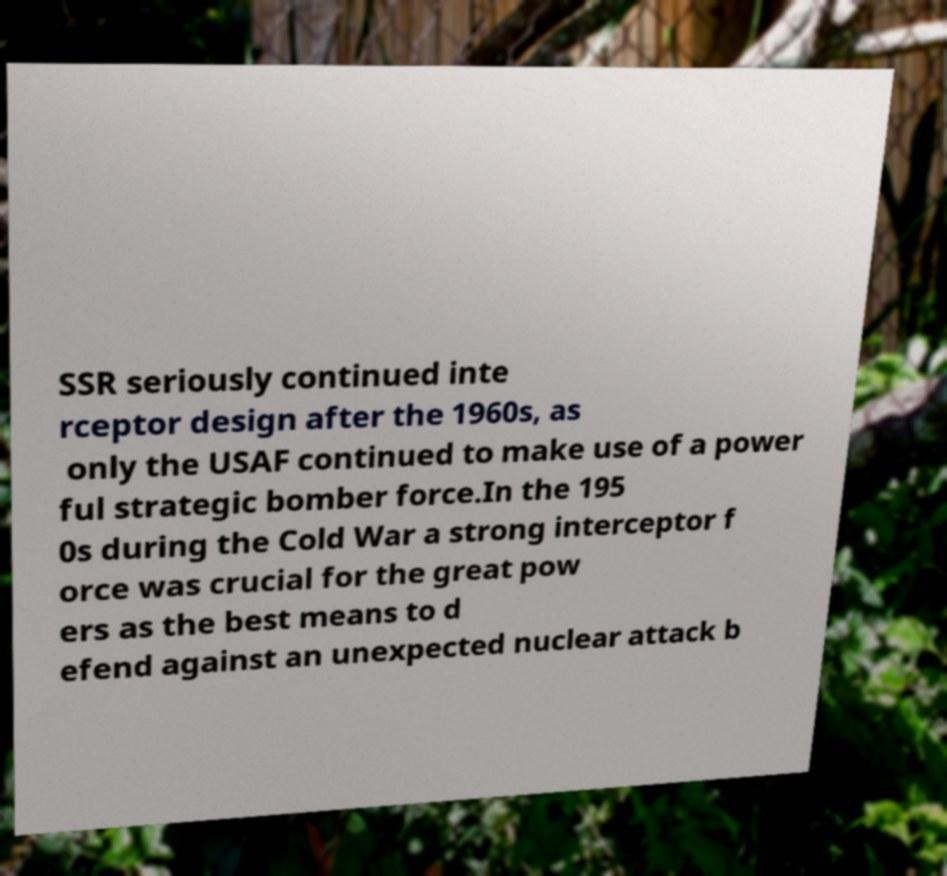What messages or text are displayed in this image? I need them in a readable, typed format. SSR seriously continued inte rceptor design after the 1960s, as only the USAF continued to make use of a power ful strategic bomber force.In the 195 0s during the Cold War a strong interceptor f orce was crucial for the great pow ers as the best means to d efend against an unexpected nuclear attack b 